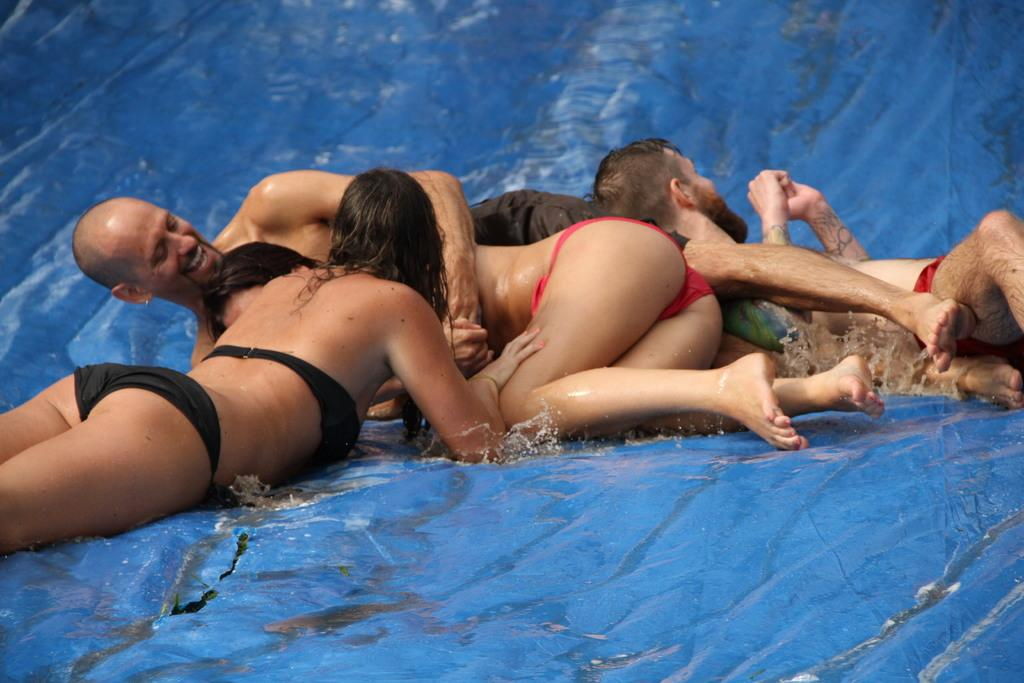What is the color of the surface where the persons are lying? The surface is blue colored. What is present on the blue colored surface? There are persons lying on the surface, and there is water on it. Where is the shelf located in the image? There is no shelf present in the image. What type of power is being generated in the image? There is no power generation depicted in the image. 